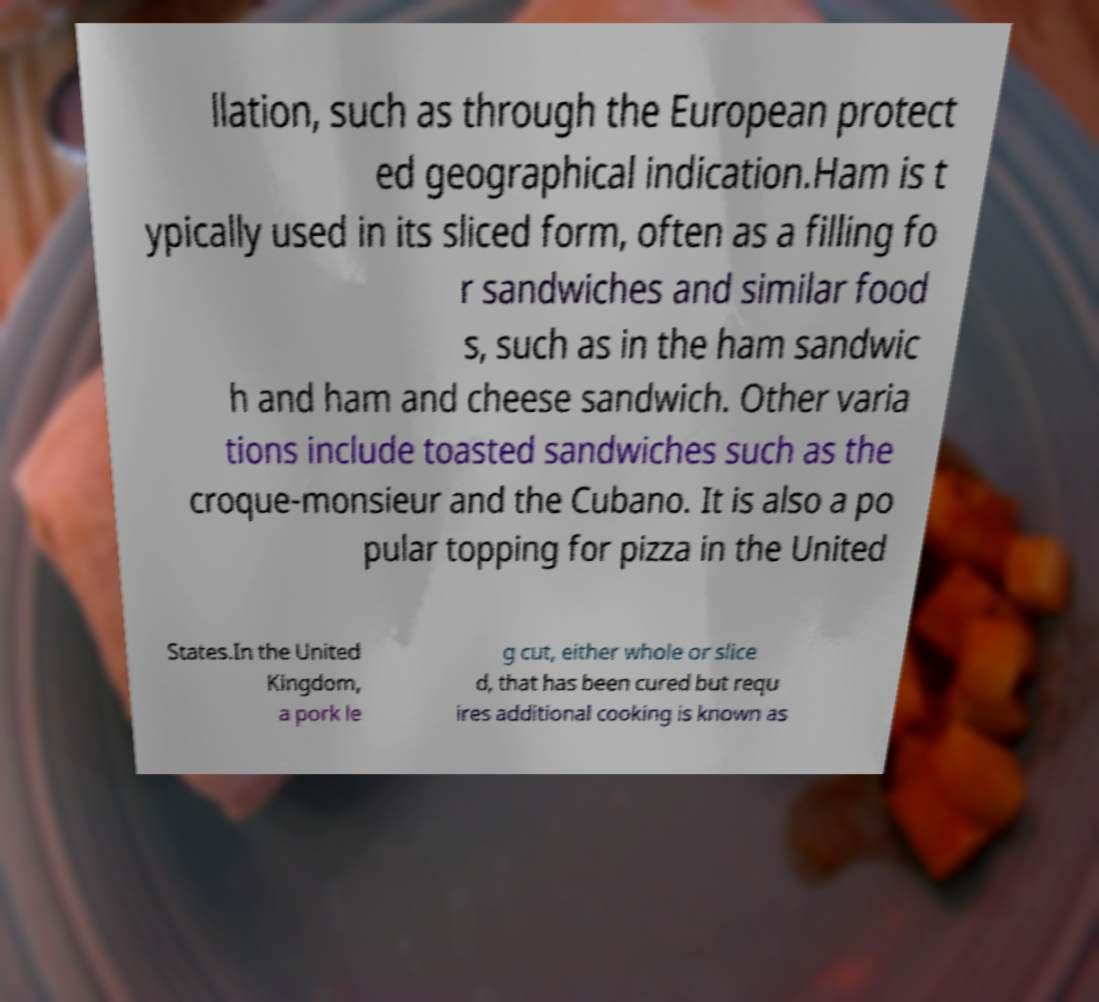Could you assist in decoding the text presented in this image and type it out clearly? llation, such as through the European protect ed geographical indication.Ham is t ypically used in its sliced form, often as a filling fo r sandwiches and similar food s, such as in the ham sandwic h and ham and cheese sandwich. Other varia tions include toasted sandwiches such as the croque-monsieur and the Cubano. It is also a po pular topping for pizza in the United States.In the United Kingdom, a pork le g cut, either whole or slice d, that has been cured but requ ires additional cooking is known as 